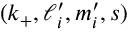<formula> <loc_0><loc_0><loc_500><loc_500>{ ( k _ { + } , \ell _ { i } ^ { \prime } , m _ { i } ^ { \prime } , s ) }</formula> 